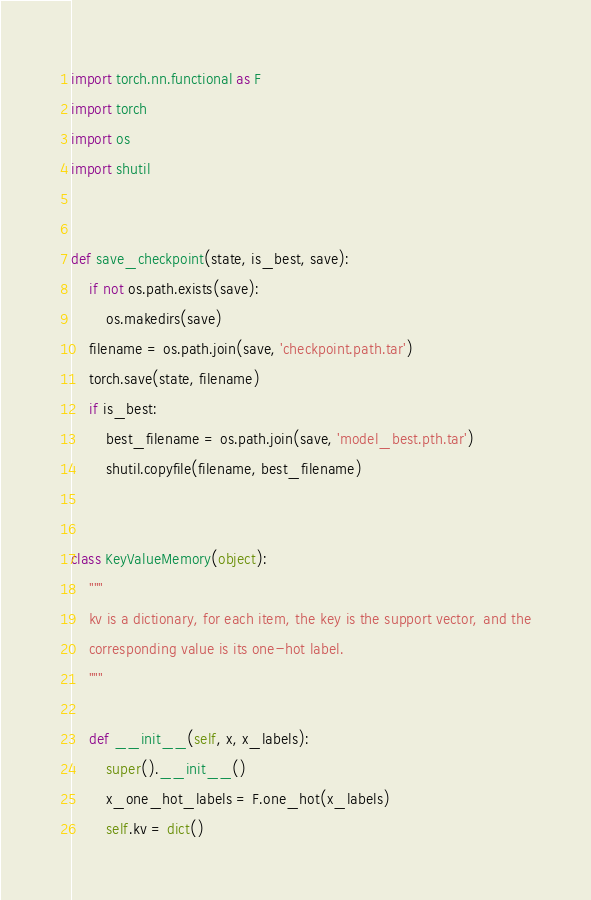Convert code to text. <code><loc_0><loc_0><loc_500><loc_500><_Python_>import torch.nn.functional as F
import torch
import os
import shutil


def save_checkpoint(state, is_best, save):
    if not os.path.exists(save):
        os.makedirs(save)
    filename = os.path.join(save, 'checkpoint.path.tar')
    torch.save(state, filename)
    if is_best:
        best_filename = os.path.join(save, 'model_best.pth.tar')
        shutil.copyfile(filename, best_filename)


class KeyValueMemory(object):
    """
    kv is a dictionary, for each item, the key is the support vector, and the
    corresponding value is its one-hot label.
    """

    def __init__(self, x, x_labels):
        super().__init__()
        x_one_hot_labels = F.one_hot(x_labels)
        self.kv = dict()</code> 